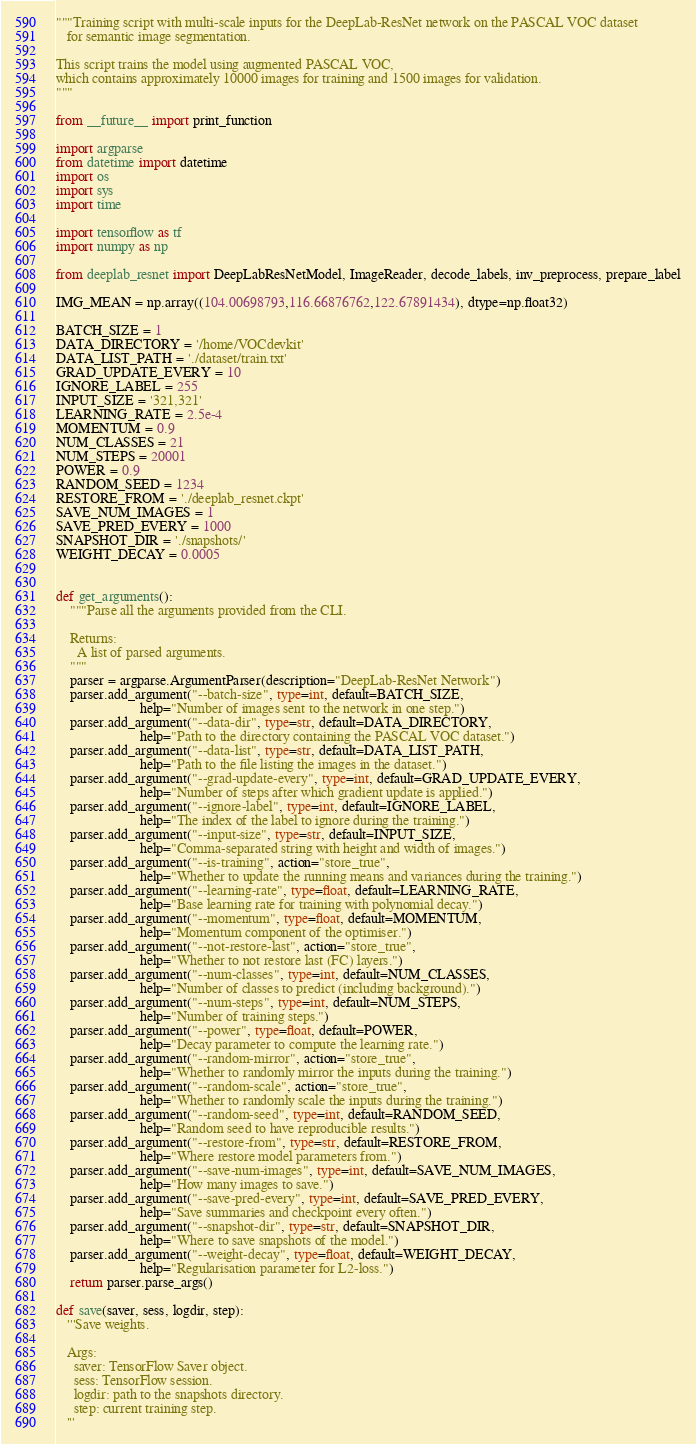Convert code to text. <code><loc_0><loc_0><loc_500><loc_500><_Python_>"""Training script with multi-scale inputs for the DeepLab-ResNet network on the PASCAL VOC dataset
   for semantic image segmentation.

This script trains the model using augmented PASCAL VOC,
which contains approximately 10000 images for training and 1500 images for validation.
"""

from __future__ import print_function

import argparse
from datetime import datetime
import os
import sys
import time

import tensorflow as tf
import numpy as np

from deeplab_resnet import DeepLabResNetModel, ImageReader, decode_labels, inv_preprocess, prepare_label

IMG_MEAN = np.array((104.00698793,116.66876762,122.67891434), dtype=np.float32)

BATCH_SIZE = 1
DATA_DIRECTORY = '/home/VOCdevkit'
DATA_LIST_PATH = './dataset/train.txt'
GRAD_UPDATE_EVERY = 10
IGNORE_LABEL = 255
INPUT_SIZE = '321,321'
LEARNING_RATE = 2.5e-4
MOMENTUM = 0.9
NUM_CLASSES = 21
NUM_STEPS = 20001
POWER = 0.9
RANDOM_SEED = 1234
RESTORE_FROM = './deeplab_resnet.ckpt'
SAVE_NUM_IMAGES = 1
SAVE_PRED_EVERY = 1000
SNAPSHOT_DIR = './snapshots/'
WEIGHT_DECAY = 0.0005


def get_arguments():
    """Parse all the arguments provided from the CLI.
    
    Returns:
      A list of parsed arguments.
    """
    parser = argparse.ArgumentParser(description="DeepLab-ResNet Network")
    parser.add_argument("--batch-size", type=int, default=BATCH_SIZE,
                        help="Number of images sent to the network in one step.")
    parser.add_argument("--data-dir", type=str, default=DATA_DIRECTORY,
                        help="Path to the directory containing the PASCAL VOC dataset.")
    parser.add_argument("--data-list", type=str, default=DATA_LIST_PATH,
                        help="Path to the file listing the images in the dataset.")
    parser.add_argument("--grad-update-every", type=int, default=GRAD_UPDATE_EVERY,
                        help="Number of steps after which gradient update is applied.")
    parser.add_argument("--ignore-label", type=int, default=IGNORE_LABEL,
                        help="The index of the label to ignore during the training.")
    parser.add_argument("--input-size", type=str, default=INPUT_SIZE,
                        help="Comma-separated string with height and width of images.")
    parser.add_argument("--is-training", action="store_true",
                        help="Whether to update the running means and variances during the training.")
    parser.add_argument("--learning-rate", type=float, default=LEARNING_RATE,
                        help="Base learning rate for training with polynomial decay.")
    parser.add_argument("--momentum", type=float, default=MOMENTUM,
                        help="Momentum component of the optimiser.")
    parser.add_argument("--not-restore-last", action="store_true",
                        help="Whether to not restore last (FC) layers.")
    parser.add_argument("--num-classes", type=int, default=NUM_CLASSES,
                        help="Number of classes to predict (including background).")
    parser.add_argument("--num-steps", type=int, default=NUM_STEPS,
                        help="Number of training steps.")
    parser.add_argument("--power", type=float, default=POWER,
                        help="Decay parameter to compute the learning rate.")
    parser.add_argument("--random-mirror", action="store_true",
                        help="Whether to randomly mirror the inputs during the training.")
    parser.add_argument("--random-scale", action="store_true",
                        help="Whether to randomly scale the inputs during the training.")
    parser.add_argument("--random-seed", type=int, default=RANDOM_SEED,
                        help="Random seed to have reproducible results.")
    parser.add_argument("--restore-from", type=str, default=RESTORE_FROM,
                        help="Where restore model parameters from.")
    parser.add_argument("--save-num-images", type=int, default=SAVE_NUM_IMAGES,
                        help="How many images to save.")
    parser.add_argument("--save-pred-every", type=int, default=SAVE_PRED_EVERY,
                        help="Save summaries and checkpoint every often.")
    parser.add_argument("--snapshot-dir", type=str, default=SNAPSHOT_DIR,
                        help="Where to save snapshots of the model.")
    parser.add_argument("--weight-decay", type=float, default=WEIGHT_DECAY,
                        help="Regularisation parameter for L2-loss.")
    return parser.parse_args()

def save(saver, sess, logdir, step):
   '''Save weights.
   
   Args:
     saver: TensorFlow Saver object.
     sess: TensorFlow session.
     logdir: path to the snapshots directory.
     step: current training step.
   '''</code> 